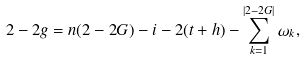<formula> <loc_0><loc_0><loc_500><loc_500>2 - 2 g = n ( 2 - 2 G ) - i - 2 ( t + h ) - \sum _ { k = 1 } ^ { | 2 - 2 G | } \omega _ { k } ,</formula> 